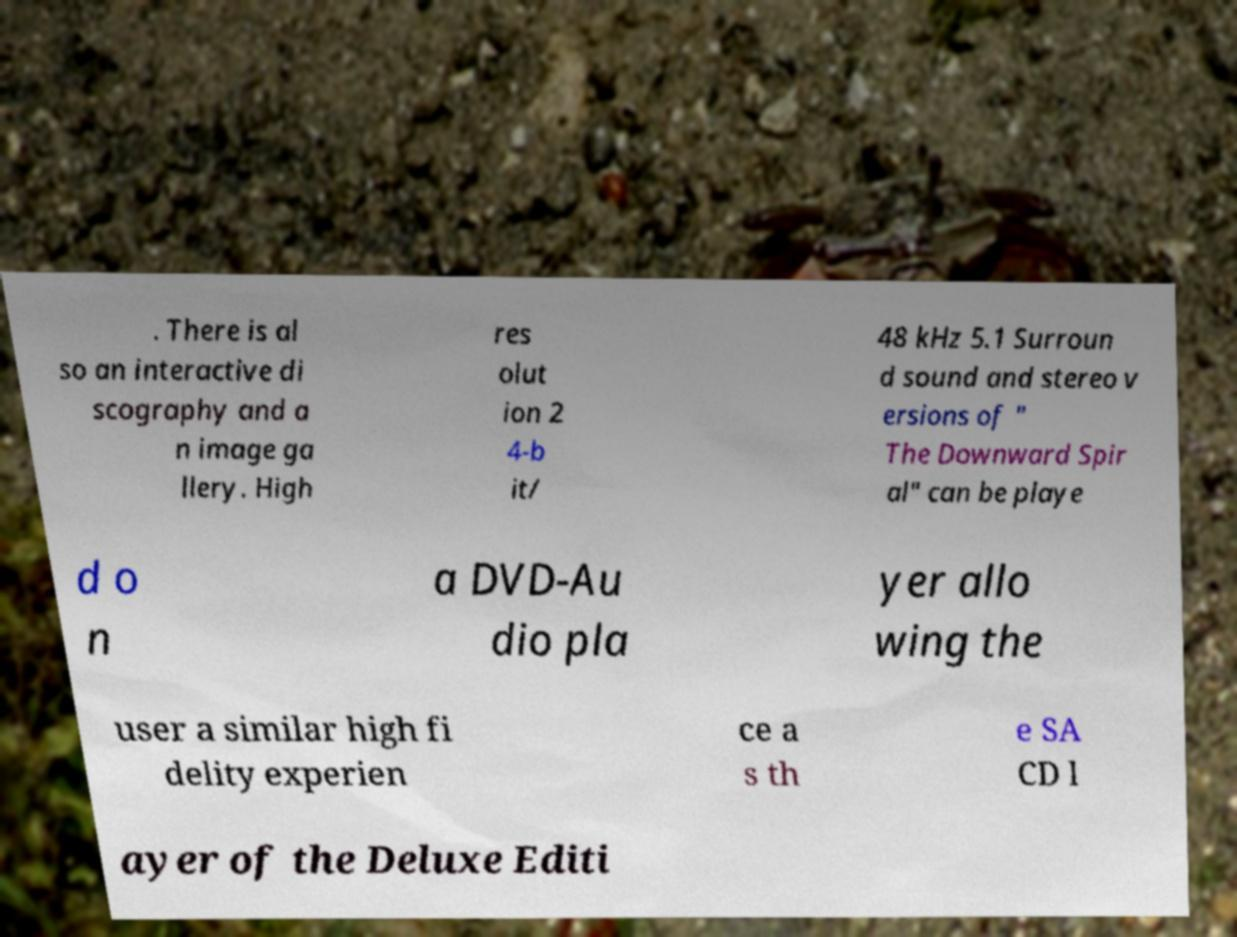Could you extract and type out the text from this image? . There is al so an interactive di scography and a n image ga llery. High res olut ion 2 4-b it/ 48 kHz 5.1 Surroun d sound and stereo v ersions of " The Downward Spir al" can be playe d o n a DVD-Au dio pla yer allo wing the user a similar high fi delity experien ce a s th e SA CD l ayer of the Deluxe Editi 